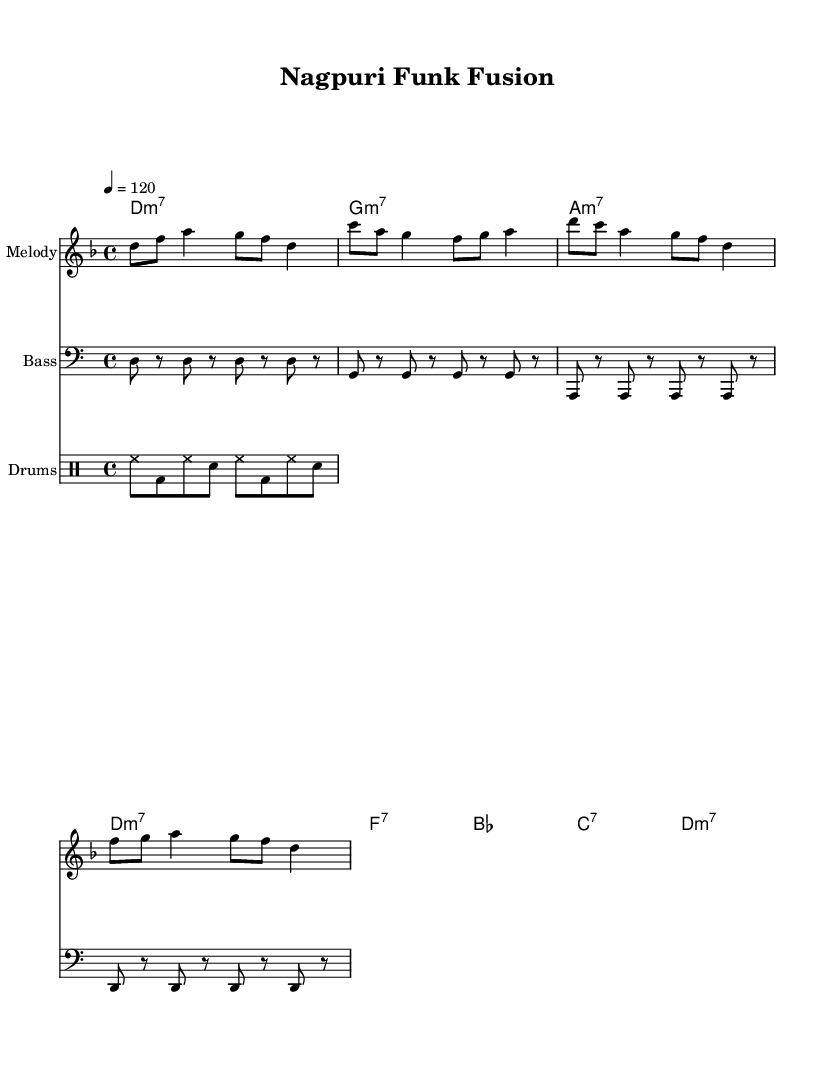What is the key signature of this music? The key signature is D minor, which consists of one flat (B flat) indicated in the sheet music.
Answer: D minor What is the time signature of the composition? The time signature is 4/4, which is indicated at the beginning of the sheet music and shows that there are four beats in each measure.
Answer: 4/4 What is the tempo marking of the piece? The tempo marking is 120 beats per minute, which is indicated in the sheet music as "4 = 120." This means the quarter note gets the beat at this pace.
Answer: 120 How many measures are in the melody section? The melody section consists of four measures, which can be counted by looking at the vertical bar lines that separate the measures.
Answer: 4 What are the first three chords in the harmony section? The first three chords are D minor 7, G minor 7, and A minor 7, which are shown in the chord names section at the beginning of the sheet music.
Answer: D minor 7, G minor 7, A minor 7 What type of drum pattern is used in this piece? The drum pattern primarily features hi-hat, bass drum, and snare, identified from the drum notation in the drum staff that repeats certain beats throughout.
Answer: Hi-hat, bass drum, snare What is the characteristic rhythm style of funk music depicted here? The funk style typically incorporates syncopation and off-beat accents, which can be seen in both the bass line and drum patterns that emphasize groove and rhythm.
Answer: Syncopation 